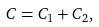<formula> <loc_0><loc_0><loc_500><loc_500>C = C _ { 1 } + C _ { 2 } ,</formula> 